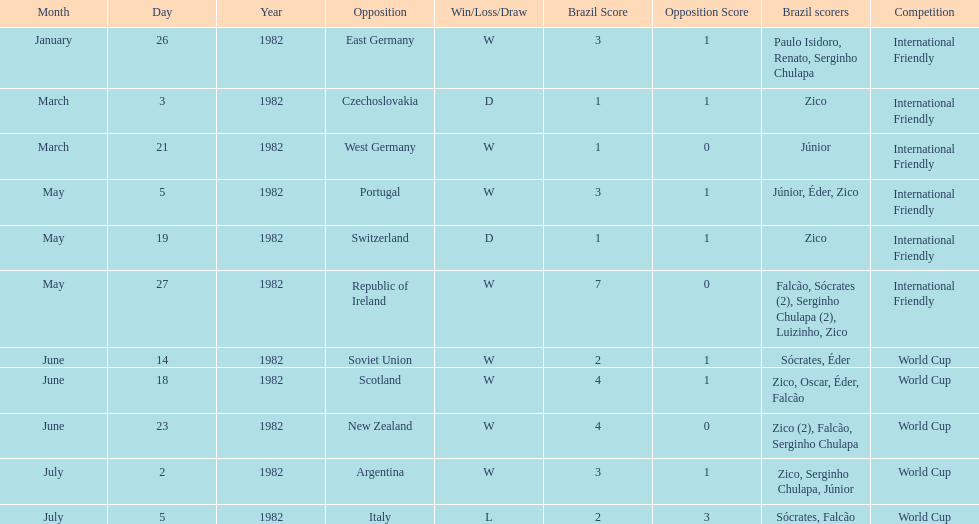What date is at the top of the list? January 26, 1982. 